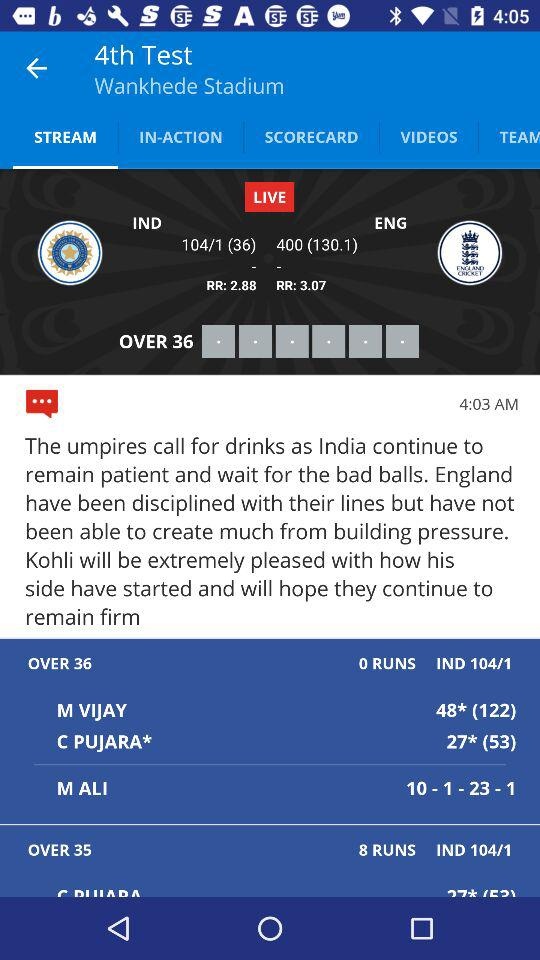Who is currently batting for India, and what are their scores? M Vijay and C Pujara are batting for India. M Vijay is at 48 runs off 122 balls, and C Pujara has scored 27 runs off 53 balls. 